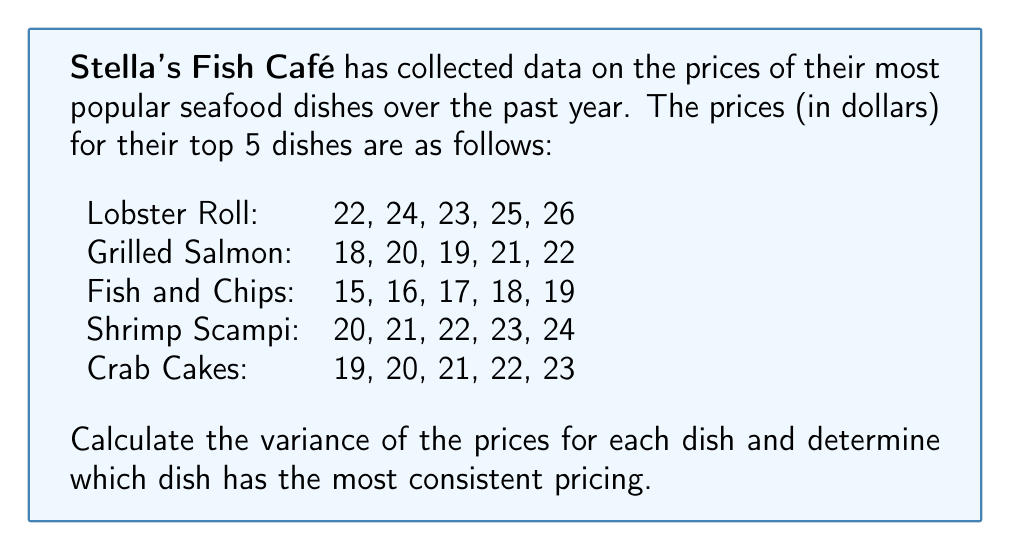Can you answer this question? To solve this problem, we need to calculate the variance for each dish's prices. The variance is a measure of variability in the data that tells us how spread out the numbers are from their average value. A lower variance indicates more consistent pricing.

The formula for variance is:

$$ \text{Variance} = \frac{\sum_{i=1}^{n} (x_i - \bar{x})^2}{n - 1} $$

Where $x_i$ are the individual values, $\bar{x}$ is the mean, and $n$ is the number of values.

Let's calculate the variance for each dish:

1. Lobster Roll:
   Mean = $(22 + 24 + 23 + 25 + 26) / 5 = 24$
   $$ \text{Variance} = \frac{(22-24)^2 + (24-24)^2 + (23-24)^2 + (25-24)^2 + (26-24)^2}{5-1} = 2.5 $$

2. Grilled Salmon:
   Mean = $(18 + 20 + 19 + 21 + 22) / 5 = 20$
   $$ \text{Variance} = \frac{(18-20)^2 + (20-20)^2 + (19-20)^2 + (21-20)^2 + (22-20)^2}{5-1} = 2.5 $$

3. Fish and Chips:
   Mean = $(15 + 16 + 17 + 18 + 19) / 5 = 17$
   $$ \text{Variance} = \frac{(15-17)^2 + (16-17)^2 + (17-17)^2 + (18-17)^2 + (19-17)^2}{5-1} = 2.5 $$

4. Shrimp Scampi:
   Mean = $(20 + 21 + 22 + 23 + 24) / 5 = 22$
   $$ \text{Variance} = \frac{(20-22)^2 + (21-22)^2 + (22-22)^2 + (23-22)^2 + (24-22)^2}{5-1} = 2.5 $$

5. Crab Cakes:
   Mean = $(19 + 20 + 21 + 22 + 23) / 5 = 21$
   $$ \text{Variance} = \frac{(19-21)^2 + (20-21)^2 + (21-21)^2 + (22-21)^2 + (23-21)^2}{5-1} = 2.5 $$

Interestingly, all dishes have the same variance of 2.5. This means that all dishes have equally consistent pricing relative to their own price ranges.
Answer: All dishes have equal pricing consistency (variance = 2.5). 